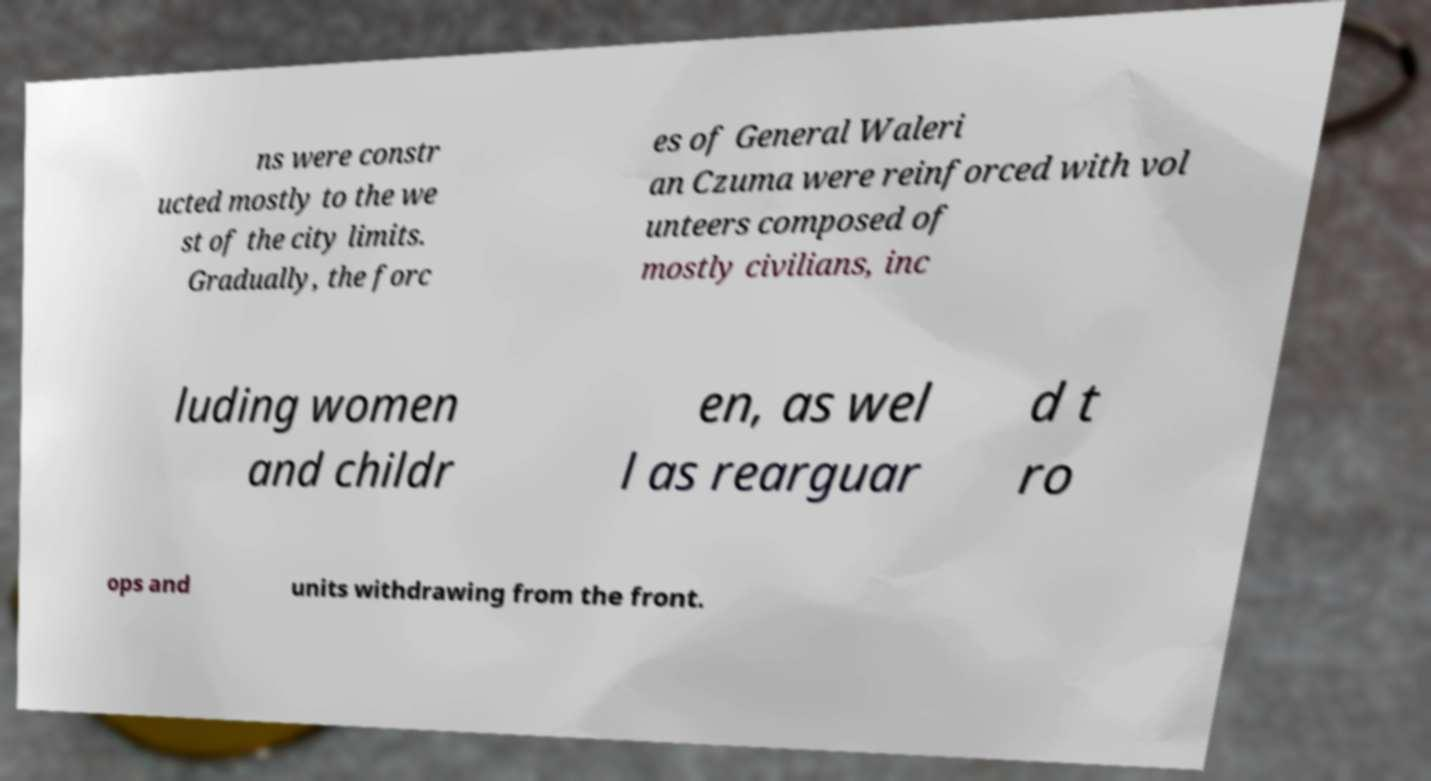What messages or text are displayed in this image? I need them in a readable, typed format. ns were constr ucted mostly to the we st of the city limits. Gradually, the forc es of General Waleri an Czuma were reinforced with vol unteers composed of mostly civilians, inc luding women and childr en, as wel l as rearguar d t ro ops and units withdrawing from the front. 